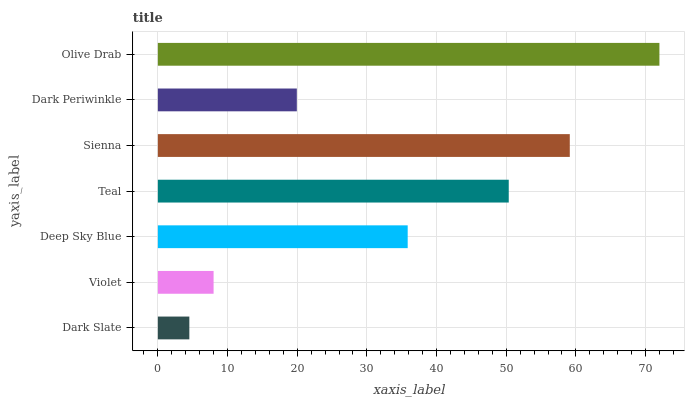Is Dark Slate the minimum?
Answer yes or no. Yes. Is Olive Drab the maximum?
Answer yes or no. Yes. Is Violet the minimum?
Answer yes or no. No. Is Violet the maximum?
Answer yes or no. No. Is Violet greater than Dark Slate?
Answer yes or no. Yes. Is Dark Slate less than Violet?
Answer yes or no. Yes. Is Dark Slate greater than Violet?
Answer yes or no. No. Is Violet less than Dark Slate?
Answer yes or no. No. Is Deep Sky Blue the high median?
Answer yes or no. Yes. Is Deep Sky Blue the low median?
Answer yes or no. Yes. Is Teal the high median?
Answer yes or no. No. Is Dark Slate the low median?
Answer yes or no. No. 